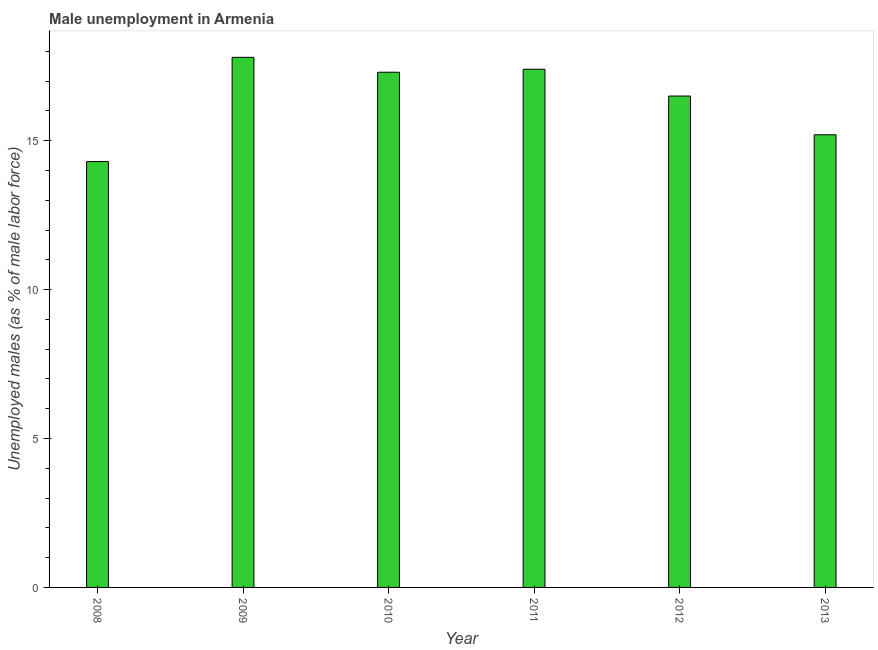Does the graph contain any zero values?
Offer a very short reply. No. What is the title of the graph?
Provide a short and direct response. Male unemployment in Armenia. What is the label or title of the Y-axis?
Give a very brief answer. Unemployed males (as % of male labor force). What is the unemployed males population in 2013?
Offer a terse response. 15.2. Across all years, what is the maximum unemployed males population?
Make the answer very short. 17.8. Across all years, what is the minimum unemployed males population?
Your answer should be compact. 14.3. In which year was the unemployed males population minimum?
Keep it short and to the point. 2008. What is the sum of the unemployed males population?
Your response must be concise. 98.5. What is the difference between the unemployed males population in 2012 and 2013?
Offer a very short reply. 1.3. What is the average unemployed males population per year?
Provide a short and direct response. 16.42. What is the median unemployed males population?
Your response must be concise. 16.9. What is the ratio of the unemployed males population in 2008 to that in 2012?
Provide a short and direct response. 0.87. What is the difference between the highest and the second highest unemployed males population?
Your answer should be very brief. 0.4. In how many years, is the unemployed males population greater than the average unemployed males population taken over all years?
Provide a succinct answer. 4. How many bars are there?
Make the answer very short. 6. Are all the bars in the graph horizontal?
Give a very brief answer. No. How many years are there in the graph?
Your response must be concise. 6. What is the difference between two consecutive major ticks on the Y-axis?
Your answer should be compact. 5. Are the values on the major ticks of Y-axis written in scientific E-notation?
Provide a succinct answer. No. What is the Unemployed males (as % of male labor force) of 2008?
Your answer should be very brief. 14.3. What is the Unemployed males (as % of male labor force) in 2009?
Your answer should be compact. 17.8. What is the Unemployed males (as % of male labor force) in 2010?
Keep it short and to the point. 17.3. What is the Unemployed males (as % of male labor force) of 2011?
Offer a terse response. 17.4. What is the Unemployed males (as % of male labor force) of 2012?
Offer a terse response. 16.5. What is the Unemployed males (as % of male labor force) of 2013?
Your answer should be very brief. 15.2. What is the difference between the Unemployed males (as % of male labor force) in 2009 and 2011?
Offer a terse response. 0.4. What is the difference between the Unemployed males (as % of male labor force) in 2010 and 2011?
Keep it short and to the point. -0.1. What is the difference between the Unemployed males (as % of male labor force) in 2010 and 2012?
Give a very brief answer. 0.8. What is the difference between the Unemployed males (as % of male labor force) in 2011 and 2013?
Your response must be concise. 2.2. What is the difference between the Unemployed males (as % of male labor force) in 2012 and 2013?
Offer a very short reply. 1.3. What is the ratio of the Unemployed males (as % of male labor force) in 2008 to that in 2009?
Your response must be concise. 0.8. What is the ratio of the Unemployed males (as % of male labor force) in 2008 to that in 2010?
Keep it short and to the point. 0.83. What is the ratio of the Unemployed males (as % of male labor force) in 2008 to that in 2011?
Provide a short and direct response. 0.82. What is the ratio of the Unemployed males (as % of male labor force) in 2008 to that in 2012?
Your answer should be very brief. 0.87. What is the ratio of the Unemployed males (as % of male labor force) in 2008 to that in 2013?
Provide a short and direct response. 0.94. What is the ratio of the Unemployed males (as % of male labor force) in 2009 to that in 2010?
Make the answer very short. 1.03. What is the ratio of the Unemployed males (as % of male labor force) in 2009 to that in 2012?
Provide a succinct answer. 1.08. What is the ratio of the Unemployed males (as % of male labor force) in 2009 to that in 2013?
Ensure brevity in your answer.  1.17. What is the ratio of the Unemployed males (as % of male labor force) in 2010 to that in 2012?
Give a very brief answer. 1.05. What is the ratio of the Unemployed males (as % of male labor force) in 2010 to that in 2013?
Give a very brief answer. 1.14. What is the ratio of the Unemployed males (as % of male labor force) in 2011 to that in 2012?
Your answer should be very brief. 1.05. What is the ratio of the Unemployed males (as % of male labor force) in 2011 to that in 2013?
Provide a succinct answer. 1.15. What is the ratio of the Unemployed males (as % of male labor force) in 2012 to that in 2013?
Give a very brief answer. 1.09. 